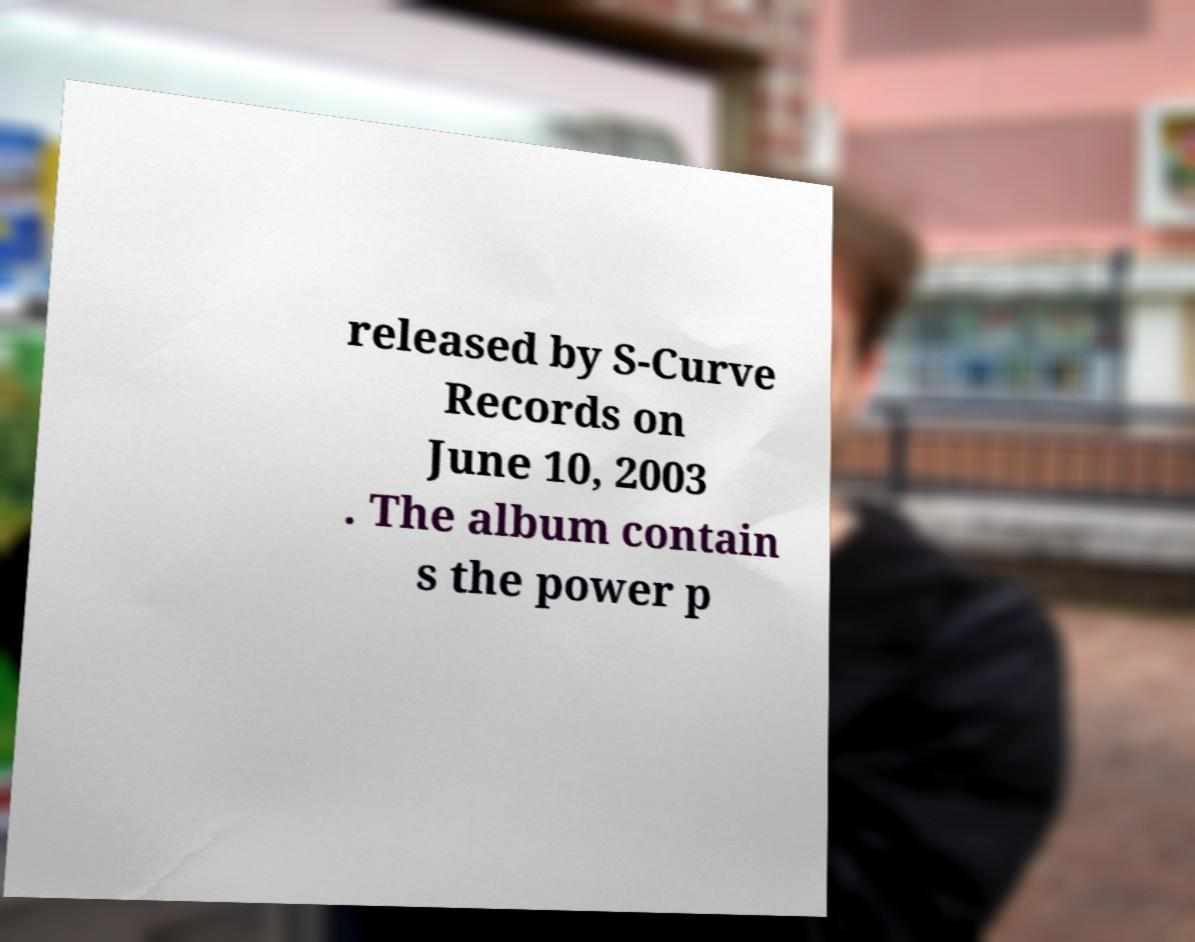Can you accurately transcribe the text from the provided image for me? released by S-Curve Records on June 10, 2003 . The album contain s the power p 